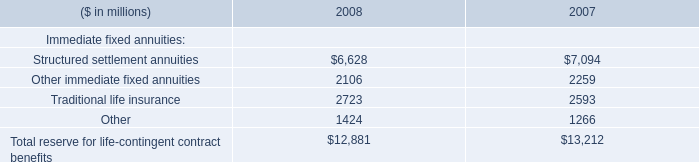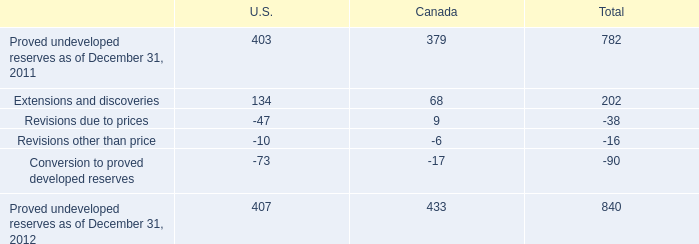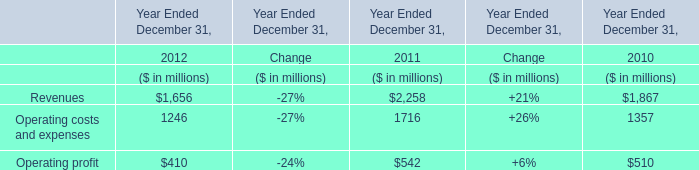If Operating profit develops with the same increasing rate as in 2011 Ended December 31, what will it reach in 2013 Ended December 31? (in million) 
Computations: ((542 * (1 + 0.06)) * (1 + 0.06))
Answer: 608.9912. 